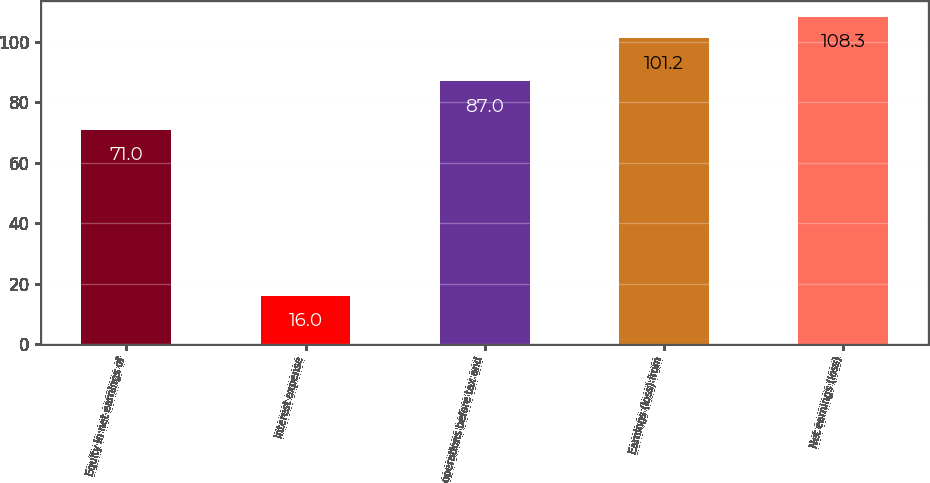<chart> <loc_0><loc_0><loc_500><loc_500><bar_chart><fcel>Equity in net earnings of<fcel>Interest expense<fcel>operations before tax and<fcel>Earnings (loss) from<fcel>Net earnings (loss)<nl><fcel>71<fcel>16<fcel>87<fcel>101.2<fcel>108.3<nl></chart> 